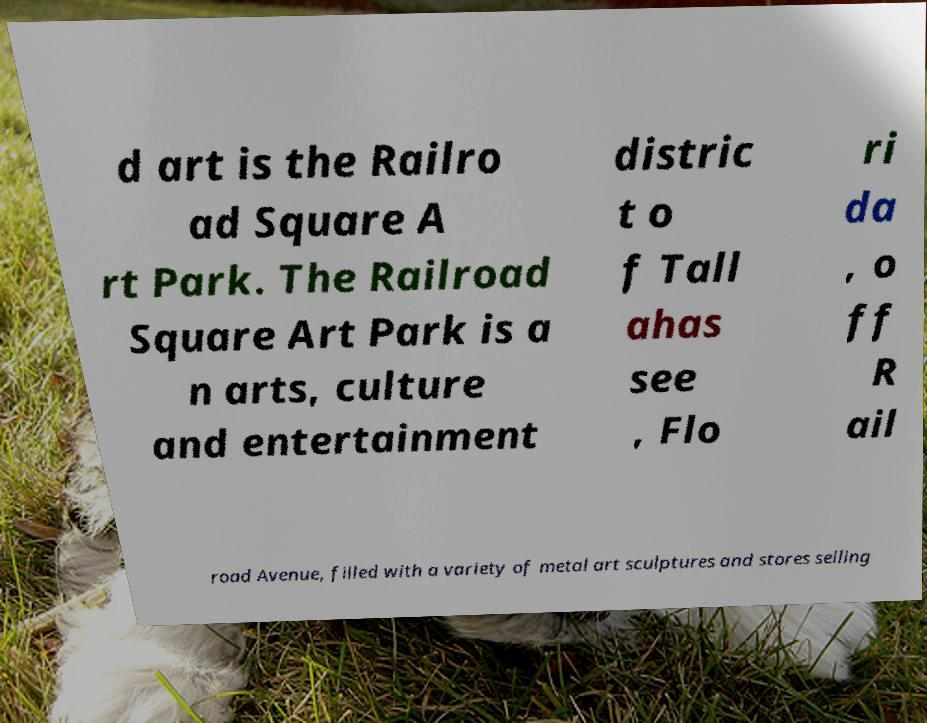Can you accurately transcribe the text from the provided image for me? d art is the Railro ad Square A rt Park. The Railroad Square Art Park is a n arts, culture and entertainment distric t o f Tall ahas see , Flo ri da , o ff R ail road Avenue, filled with a variety of metal art sculptures and stores selling 